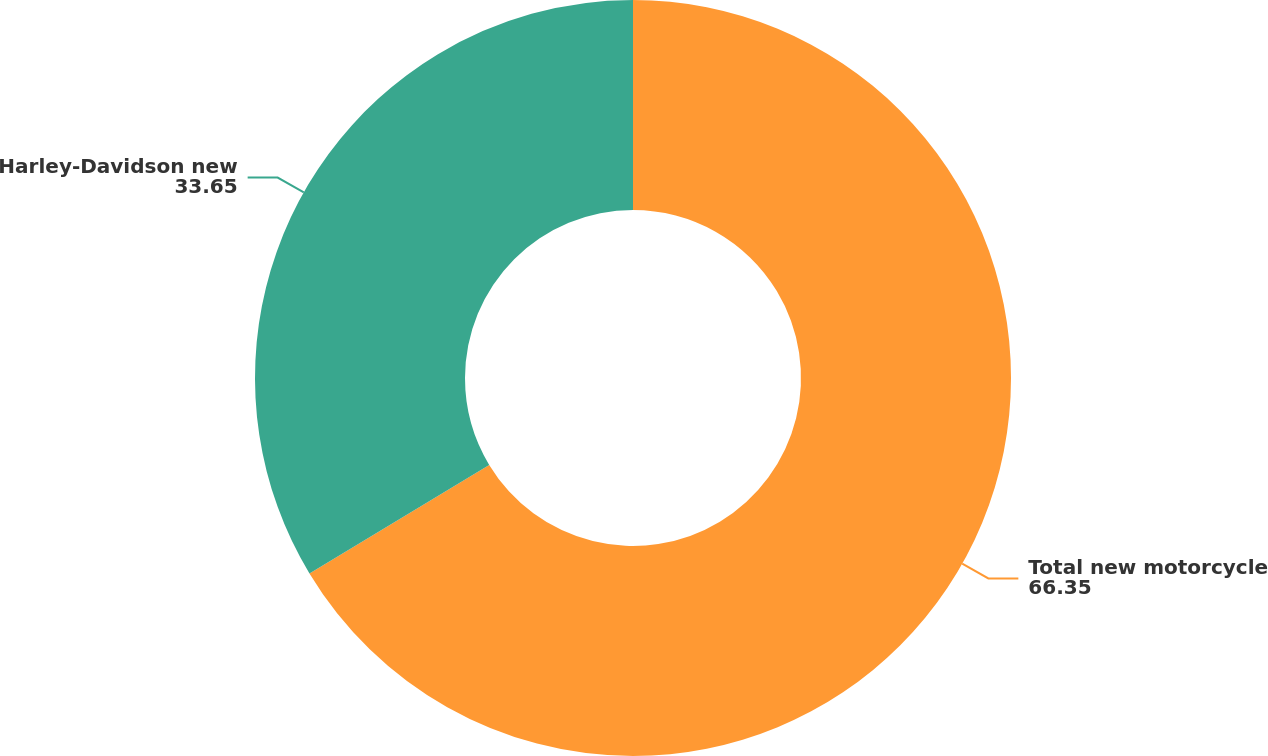<chart> <loc_0><loc_0><loc_500><loc_500><pie_chart><fcel>Total new motorcycle<fcel>Harley-Davidson new<nl><fcel>66.35%<fcel>33.65%<nl></chart> 